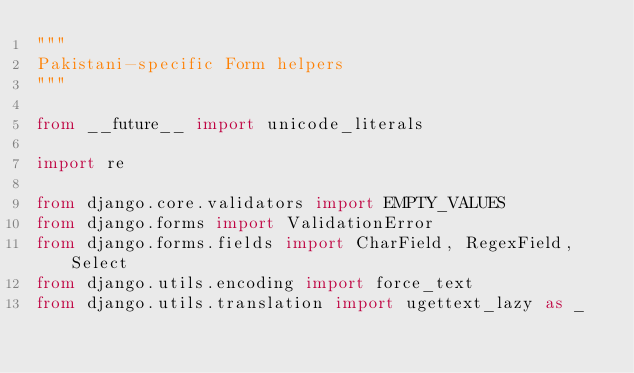Convert code to text. <code><loc_0><loc_0><loc_500><loc_500><_Python_>"""
Pakistani-specific Form helpers
"""

from __future__ import unicode_literals

import re

from django.core.validators import EMPTY_VALUES
from django.forms import ValidationError
from django.forms.fields import CharField, RegexField, Select
from django.utils.encoding import force_text
from django.utils.translation import ugettext_lazy as _
</code> 